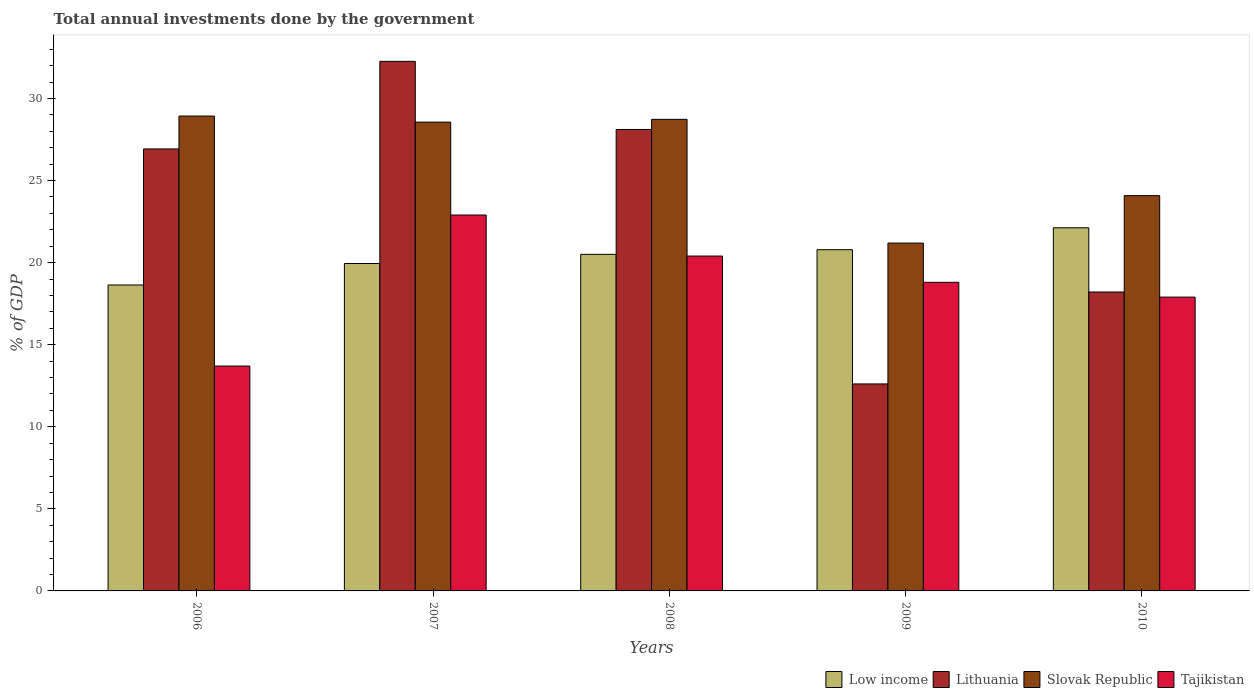How many different coloured bars are there?
Make the answer very short. 4. Are the number of bars per tick equal to the number of legend labels?
Ensure brevity in your answer.  Yes. How many bars are there on the 1st tick from the right?
Keep it short and to the point. 4. What is the label of the 3rd group of bars from the left?
Provide a succinct answer. 2008. In how many cases, is the number of bars for a given year not equal to the number of legend labels?
Provide a succinct answer. 0. What is the total annual investments done by the government in Lithuania in 2006?
Offer a terse response. 26.93. Across all years, what is the maximum total annual investments done by the government in Tajikistan?
Ensure brevity in your answer.  22.9. Across all years, what is the minimum total annual investments done by the government in Low income?
Ensure brevity in your answer.  18.64. What is the total total annual investments done by the government in Low income in the graph?
Keep it short and to the point. 102. What is the difference between the total annual investments done by the government in Lithuania in 2006 and that in 2009?
Provide a succinct answer. 14.32. What is the difference between the total annual investments done by the government in Tajikistan in 2010 and the total annual investments done by the government in Lithuania in 2006?
Ensure brevity in your answer.  -9.03. What is the average total annual investments done by the government in Low income per year?
Give a very brief answer. 20.4. In the year 2009, what is the difference between the total annual investments done by the government in Lithuania and total annual investments done by the government in Slovak Republic?
Your answer should be compact. -8.58. In how many years, is the total annual investments done by the government in Slovak Republic greater than 11 %?
Give a very brief answer. 5. What is the ratio of the total annual investments done by the government in Tajikistan in 2006 to that in 2009?
Offer a terse response. 0.73. Is the difference between the total annual investments done by the government in Lithuania in 2006 and 2009 greater than the difference between the total annual investments done by the government in Slovak Republic in 2006 and 2009?
Keep it short and to the point. Yes. What is the difference between the highest and the second highest total annual investments done by the government in Low income?
Offer a very short reply. 1.34. What is the difference between the highest and the lowest total annual investments done by the government in Lithuania?
Offer a terse response. 19.65. In how many years, is the total annual investments done by the government in Slovak Republic greater than the average total annual investments done by the government in Slovak Republic taken over all years?
Keep it short and to the point. 3. Is the sum of the total annual investments done by the government in Lithuania in 2007 and 2010 greater than the maximum total annual investments done by the government in Low income across all years?
Offer a very short reply. Yes. What does the 2nd bar from the left in 2009 represents?
Your response must be concise. Lithuania. What does the 1st bar from the right in 2010 represents?
Offer a very short reply. Tajikistan. Is it the case that in every year, the sum of the total annual investments done by the government in Lithuania and total annual investments done by the government in Low income is greater than the total annual investments done by the government in Slovak Republic?
Ensure brevity in your answer.  Yes. How many bars are there?
Give a very brief answer. 20. How many years are there in the graph?
Keep it short and to the point. 5. Does the graph contain any zero values?
Give a very brief answer. No. Does the graph contain grids?
Offer a terse response. No. How are the legend labels stacked?
Give a very brief answer. Horizontal. What is the title of the graph?
Ensure brevity in your answer.  Total annual investments done by the government. Does "India" appear as one of the legend labels in the graph?
Provide a succinct answer. No. What is the label or title of the Y-axis?
Provide a short and direct response. % of GDP. What is the % of GDP of Low income in 2006?
Your response must be concise. 18.64. What is the % of GDP of Lithuania in 2006?
Give a very brief answer. 26.93. What is the % of GDP in Slovak Republic in 2006?
Provide a short and direct response. 28.93. What is the % of GDP of Low income in 2007?
Provide a short and direct response. 19.95. What is the % of GDP in Lithuania in 2007?
Provide a succinct answer. 32.26. What is the % of GDP of Slovak Republic in 2007?
Make the answer very short. 28.56. What is the % of GDP in Tajikistan in 2007?
Keep it short and to the point. 22.9. What is the % of GDP of Low income in 2008?
Make the answer very short. 20.5. What is the % of GDP in Lithuania in 2008?
Keep it short and to the point. 28.11. What is the % of GDP in Slovak Republic in 2008?
Provide a succinct answer. 28.73. What is the % of GDP in Tajikistan in 2008?
Your response must be concise. 20.4. What is the % of GDP in Low income in 2009?
Ensure brevity in your answer.  20.79. What is the % of GDP of Lithuania in 2009?
Keep it short and to the point. 12.61. What is the % of GDP in Slovak Republic in 2009?
Your response must be concise. 21.19. What is the % of GDP of Low income in 2010?
Your answer should be very brief. 22.12. What is the % of GDP in Lithuania in 2010?
Your response must be concise. 18.21. What is the % of GDP in Slovak Republic in 2010?
Ensure brevity in your answer.  24.08. What is the % of GDP in Tajikistan in 2010?
Provide a succinct answer. 17.9. Across all years, what is the maximum % of GDP in Low income?
Provide a succinct answer. 22.12. Across all years, what is the maximum % of GDP of Lithuania?
Your answer should be very brief. 32.26. Across all years, what is the maximum % of GDP in Slovak Republic?
Your answer should be very brief. 28.93. Across all years, what is the maximum % of GDP of Tajikistan?
Provide a short and direct response. 22.9. Across all years, what is the minimum % of GDP in Low income?
Make the answer very short. 18.64. Across all years, what is the minimum % of GDP of Lithuania?
Provide a short and direct response. 12.61. Across all years, what is the minimum % of GDP in Slovak Republic?
Give a very brief answer. 21.19. Across all years, what is the minimum % of GDP in Tajikistan?
Ensure brevity in your answer.  13.7. What is the total % of GDP in Low income in the graph?
Provide a short and direct response. 102. What is the total % of GDP in Lithuania in the graph?
Make the answer very short. 118.12. What is the total % of GDP in Slovak Republic in the graph?
Provide a short and direct response. 131.49. What is the total % of GDP of Tajikistan in the graph?
Your answer should be compact. 93.7. What is the difference between the % of GDP of Low income in 2006 and that in 2007?
Offer a very short reply. -1.31. What is the difference between the % of GDP of Lithuania in 2006 and that in 2007?
Your answer should be very brief. -5.33. What is the difference between the % of GDP of Slovak Republic in 2006 and that in 2007?
Give a very brief answer. 0.37. What is the difference between the % of GDP in Low income in 2006 and that in 2008?
Offer a very short reply. -1.87. What is the difference between the % of GDP in Lithuania in 2006 and that in 2008?
Your answer should be compact. -1.19. What is the difference between the % of GDP of Slovak Republic in 2006 and that in 2008?
Provide a succinct answer. 0.2. What is the difference between the % of GDP of Tajikistan in 2006 and that in 2008?
Offer a very short reply. -6.7. What is the difference between the % of GDP of Low income in 2006 and that in 2009?
Your answer should be compact. -2.15. What is the difference between the % of GDP of Lithuania in 2006 and that in 2009?
Your answer should be compact. 14.32. What is the difference between the % of GDP in Slovak Republic in 2006 and that in 2009?
Keep it short and to the point. 7.74. What is the difference between the % of GDP of Tajikistan in 2006 and that in 2009?
Provide a succinct answer. -5.1. What is the difference between the % of GDP of Low income in 2006 and that in 2010?
Offer a very short reply. -3.48. What is the difference between the % of GDP of Lithuania in 2006 and that in 2010?
Keep it short and to the point. 8.72. What is the difference between the % of GDP of Slovak Republic in 2006 and that in 2010?
Your answer should be very brief. 4.85. What is the difference between the % of GDP of Low income in 2007 and that in 2008?
Provide a short and direct response. -0.56. What is the difference between the % of GDP in Lithuania in 2007 and that in 2008?
Ensure brevity in your answer.  4.15. What is the difference between the % of GDP in Slovak Republic in 2007 and that in 2008?
Make the answer very short. -0.17. What is the difference between the % of GDP in Low income in 2007 and that in 2009?
Your response must be concise. -0.84. What is the difference between the % of GDP of Lithuania in 2007 and that in 2009?
Offer a very short reply. 19.65. What is the difference between the % of GDP in Slovak Republic in 2007 and that in 2009?
Your answer should be very brief. 7.37. What is the difference between the % of GDP in Tajikistan in 2007 and that in 2009?
Ensure brevity in your answer.  4.1. What is the difference between the % of GDP of Low income in 2007 and that in 2010?
Ensure brevity in your answer.  -2.18. What is the difference between the % of GDP in Lithuania in 2007 and that in 2010?
Provide a short and direct response. 14.05. What is the difference between the % of GDP in Slovak Republic in 2007 and that in 2010?
Provide a succinct answer. 4.48. What is the difference between the % of GDP in Low income in 2008 and that in 2009?
Your answer should be compact. -0.28. What is the difference between the % of GDP of Lithuania in 2008 and that in 2009?
Offer a very short reply. 15.5. What is the difference between the % of GDP in Slovak Republic in 2008 and that in 2009?
Give a very brief answer. 7.54. What is the difference between the % of GDP of Low income in 2008 and that in 2010?
Keep it short and to the point. -1.62. What is the difference between the % of GDP in Lithuania in 2008 and that in 2010?
Make the answer very short. 9.9. What is the difference between the % of GDP in Slovak Republic in 2008 and that in 2010?
Your answer should be very brief. 4.65. What is the difference between the % of GDP in Low income in 2009 and that in 2010?
Give a very brief answer. -1.34. What is the difference between the % of GDP of Lithuania in 2009 and that in 2010?
Offer a very short reply. -5.6. What is the difference between the % of GDP in Slovak Republic in 2009 and that in 2010?
Give a very brief answer. -2.89. What is the difference between the % of GDP of Low income in 2006 and the % of GDP of Lithuania in 2007?
Provide a short and direct response. -13.62. What is the difference between the % of GDP in Low income in 2006 and the % of GDP in Slovak Republic in 2007?
Your response must be concise. -9.92. What is the difference between the % of GDP in Low income in 2006 and the % of GDP in Tajikistan in 2007?
Provide a succinct answer. -4.26. What is the difference between the % of GDP of Lithuania in 2006 and the % of GDP of Slovak Republic in 2007?
Your answer should be compact. -1.63. What is the difference between the % of GDP in Lithuania in 2006 and the % of GDP in Tajikistan in 2007?
Ensure brevity in your answer.  4.03. What is the difference between the % of GDP of Slovak Republic in 2006 and the % of GDP of Tajikistan in 2007?
Offer a terse response. 6.03. What is the difference between the % of GDP in Low income in 2006 and the % of GDP in Lithuania in 2008?
Ensure brevity in your answer.  -9.47. What is the difference between the % of GDP in Low income in 2006 and the % of GDP in Slovak Republic in 2008?
Give a very brief answer. -10.09. What is the difference between the % of GDP in Low income in 2006 and the % of GDP in Tajikistan in 2008?
Offer a terse response. -1.76. What is the difference between the % of GDP in Lithuania in 2006 and the % of GDP in Slovak Republic in 2008?
Offer a terse response. -1.8. What is the difference between the % of GDP in Lithuania in 2006 and the % of GDP in Tajikistan in 2008?
Keep it short and to the point. 6.53. What is the difference between the % of GDP in Slovak Republic in 2006 and the % of GDP in Tajikistan in 2008?
Your answer should be very brief. 8.53. What is the difference between the % of GDP in Low income in 2006 and the % of GDP in Lithuania in 2009?
Ensure brevity in your answer.  6.03. What is the difference between the % of GDP in Low income in 2006 and the % of GDP in Slovak Republic in 2009?
Offer a terse response. -2.55. What is the difference between the % of GDP of Low income in 2006 and the % of GDP of Tajikistan in 2009?
Keep it short and to the point. -0.16. What is the difference between the % of GDP of Lithuania in 2006 and the % of GDP of Slovak Republic in 2009?
Ensure brevity in your answer.  5.74. What is the difference between the % of GDP in Lithuania in 2006 and the % of GDP in Tajikistan in 2009?
Provide a short and direct response. 8.13. What is the difference between the % of GDP of Slovak Republic in 2006 and the % of GDP of Tajikistan in 2009?
Your response must be concise. 10.13. What is the difference between the % of GDP of Low income in 2006 and the % of GDP of Lithuania in 2010?
Provide a succinct answer. 0.43. What is the difference between the % of GDP in Low income in 2006 and the % of GDP in Slovak Republic in 2010?
Provide a short and direct response. -5.44. What is the difference between the % of GDP of Low income in 2006 and the % of GDP of Tajikistan in 2010?
Keep it short and to the point. 0.74. What is the difference between the % of GDP in Lithuania in 2006 and the % of GDP in Slovak Republic in 2010?
Your answer should be very brief. 2.85. What is the difference between the % of GDP of Lithuania in 2006 and the % of GDP of Tajikistan in 2010?
Your answer should be very brief. 9.03. What is the difference between the % of GDP in Slovak Republic in 2006 and the % of GDP in Tajikistan in 2010?
Your answer should be very brief. 11.03. What is the difference between the % of GDP in Low income in 2007 and the % of GDP in Lithuania in 2008?
Ensure brevity in your answer.  -8.17. What is the difference between the % of GDP of Low income in 2007 and the % of GDP of Slovak Republic in 2008?
Ensure brevity in your answer.  -8.78. What is the difference between the % of GDP of Low income in 2007 and the % of GDP of Tajikistan in 2008?
Your answer should be very brief. -0.45. What is the difference between the % of GDP in Lithuania in 2007 and the % of GDP in Slovak Republic in 2008?
Keep it short and to the point. 3.53. What is the difference between the % of GDP of Lithuania in 2007 and the % of GDP of Tajikistan in 2008?
Your answer should be compact. 11.86. What is the difference between the % of GDP in Slovak Republic in 2007 and the % of GDP in Tajikistan in 2008?
Provide a short and direct response. 8.16. What is the difference between the % of GDP in Low income in 2007 and the % of GDP in Lithuania in 2009?
Offer a terse response. 7.34. What is the difference between the % of GDP in Low income in 2007 and the % of GDP in Slovak Republic in 2009?
Make the answer very short. -1.25. What is the difference between the % of GDP of Low income in 2007 and the % of GDP of Tajikistan in 2009?
Ensure brevity in your answer.  1.15. What is the difference between the % of GDP in Lithuania in 2007 and the % of GDP in Slovak Republic in 2009?
Your answer should be very brief. 11.07. What is the difference between the % of GDP in Lithuania in 2007 and the % of GDP in Tajikistan in 2009?
Give a very brief answer. 13.46. What is the difference between the % of GDP in Slovak Republic in 2007 and the % of GDP in Tajikistan in 2009?
Provide a short and direct response. 9.76. What is the difference between the % of GDP of Low income in 2007 and the % of GDP of Lithuania in 2010?
Ensure brevity in your answer.  1.74. What is the difference between the % of GDP of Low income in 2007 and the % of GDP of Slovak Republic in 2010?
Keep it short and to the point. -4.14. What is the difference between the % of GDP of Low income in 2007 and the % of GDP of Tajikistan in 2010?
Your response must be concise. 2.05. What is the difference between the % of GDP in Lithuania in 2007 and the % of GDP in Slovak Republic in 2010?
Offer a terse response. 8.18. What is the difference between the % of GDP of Lithuania in 2007 and the % of GDP of Tajikistan in 2010?
Your answer should be very brief. 14.36. What is the difference between the % of GDP of Slovak Republic in 2007 and the % of GDP of Tajikistan in 2010?
Provide a short and direct response. 10.66. What is the difference between the % of GDP of Low income in 2008 and the % of GDP of Lithuania in 2009?
Your response must be concise. 7.89. What is the difference between the % of GDP of Low income in 2008 and the % of GDP of Slovak Republic in 2009?
Offer a terse response. -0.69. What is the difference between the % of GDP of Low income in 2008 and the % of GDP of Tajikistan in 2009?
Make the answer very short. 1.7. What is the difference between the % of GDP of Lithuania in 2008 and the % of GDP of Slovak Republic in 2009?
Offer a very short reply. 6.92. What is the difference between the % of GDP in Lithuania in 2008 and the % of GDP in Tajikistan in 2009?
Give a very brief answer. 9.31. What is the difference between the % of GDP of Slovak Republic in 2008 and the % of GDP of Tajikistan in 2009?
Give a very brief answer. 9.93. What is the difference between the % of GDP of Low income in 2008 and the % of GDP of Lithuania in 2010?
Provide a succinct answer. 2.29. What is the difference between the % of GDP of Low income in 2008 and the % of GDP of Slovak Republic in 2010?
Provide a succinct answer. -3.58. What is the difference between the % of GDP in Low income in 2008 and the % of GDP in Tajikistan in 2010?
Your response must be concise. 2.6. What is the difference between the % of GDP of Lithuania in 2008 and the % of GDP of Slovak Republic in 2010?
Offer a very short reply. 4.03. What is the difference between the % of GDP of Lithuania in 2008 and the % of GDP of Tajikistan in 2010?
Offer a terse response. 10.21. What is the difference between the % of GDP of Slovak Republic in 2008 and the % of GDP of Tajikistan in 2010?
Offer a very short reply. 10.83. What is the difference between the % of GDP of Low income in 2009 and the % of GDP of Lithuania in 2010?
Offer a terse response. 2.58. What is the difference between the % of GDP of Low income in 2009 and the % of GDP of Slovak Republic in 2010?
Offer a very short reply. -3.29. What is the difference between the % of GDP in Low income in 2009 and the % of GDP in Tajikistan in 2010?
Give a very brief answer. 2.89. What is the difference between the % of GDP in Lithuania in 2009 and the % of GDP in Slovak Republic in 2010?
Your answer should be very brief. -11.47. What is the difference between the % of GDP of Lithuania in 2009 and the % of GDP of Tajikistan in 2010?
Ensure brevity in your answer.  -5.29. What is the difference between the % of GDP of Slovak Republic in 2009 and the % of GDP of Tajikistan in 2010?
Provide a succinct answer. 3.29. What is the average % of GDP in Low income per year?
Provide a short and direct response. 20.4. What is the average % of GDP in Lithuania per year?
Offer a terse response. 23.62. What is the average % of GDP in Slovak Republic per year?
Your answer should be compact. 26.3. What is the average % of GDP in Tajikistan per year?
Ensure brevity in your answer.  18.74. In the year 2006, what is the difference between the % of GDP of Low income and % of GDP of Lithuania?
Offer a very short reply. -8.29. In the year 2006, what is the difference between the % of GDP of Low income and % of GDP of Slovak Republic?
Provide a short and direct response. -10.29. In the year 2006, what is the difference between the % of GDP in Low income and % of GDP in Tajikistan?
Ensure brevity in your answer.  4.94. In the year 2006, what is the difference between the % of GDP of Lithuania and % of GDP of Slovak Republic?
Your answer should be very brief. -2. In the year 2006, what is the difference between the % of GDP in Lithuania and % of GDP in Tajikistan?
Make the answer very short. 13.23. In the year 2006, what is the difference between the % of GDP of Slovak Republic and % of GDP of Tajikistan?
Your answer should be very brief. 15.23. In the year 2007, what is the difference between the % of GDP of Low income and % of GDP of Lithuania?
Your answer should be compact. -12.32. In the year 2007, what is the difference between the % of GDP in Low income and % of GDP in Slovak Republic?
Provide a short and direct response. -8.61. In the year 2007, what is the difference between the % of GDP in Low income and % of GDP in Tajikistan?
Provide a succinct answer. -2.95. In the year 2007, what is the difference between the % of GDP of Lithuania and % of GDP of Slovak Republic?
Your answer should be very brief. 3.7. In the year 2007, what is the difference between the % of GDP of Lithuania and % of GDP of Tajikistan?
Provide a short and direct response. 9.36. In the year 2007, what is the difference between the % of GDP of Slovak Republic and % of GDP of Tajikistan?
Offer a very short reply. 5.66. In the year 2008, what is the difference between the % of GDP in Low income and % of GDP in Lithuania?
Ensure brevity in your answer.  -7.61. In the year 2008, what is the difference between the % of GDP of Low income and % of GDP of Slovak Republic?
Keep it short and to the point. -8.22. In the year 2008, what is the difference between the % of GDP of Low income and % of GDP of Tajikistan?
Offer a very short reply. 0.1. In the year 2008, what is the difference between the % of GDP in Lithuania and % of GDP in Slovak Republic?
Provide a short and direct response. -0.62. In the year 2008, what is the difference between the % of GDP in Lithuania and % of GDP in Tajikistan?
Ensure brevity in your answer.  7.71. In the year 2008, what is the difference between the % of GDP of Slovak Republic and % of GDP of Tajikistan?
Offer a terse response. 8.33. In the year 2009, what is the difference between the % of GDP of Low income and % of GDP of Lithuania?
Make the answer very short. 8.18. In the year 2009, what is the difference between the % of GDP in Low income and % of GDP in Slovak Republic?
Offer a very short reply. -0.4. In the year 2009, what is the difference between the % of GDP of Low income and % of GDP of Tajikistan?
Give a very brief answer. 1.99. In the year 2009, what is the difference between the % of GDP of Lithuania and % of GDP of Slovak Republic?
Your answer should be very brief. -8.58. In the year 2009, what is the difference between the % of GDP of Lithuania and % of GDP of Tajikistan?
Give a very brief answer. -6.19. In the year 2009, what is the difference between the % of GDP of Slovak Republic and % of GDP of Tajikistan?
Your answer should be very brief. 2.39. In the year 2010, what is the difference between the % of GDP of Low income and % of GDP of Lithuania?
Your answer should be compact. 3.91. In the year 2010, what is the difference between the % of GDP in Low income and % of GDP in Slovak Republic?
Ensure brevity in your answer.  -1.96. In the year 2010, what is the difference between the % of GDP in Low income and % of GDP in Tajikistan?
Your response must be concise. 4.22. In the year 2010, what is the difference between the % of GDP of Lithuania and % of GDP of Slovak Republic?
Offer a very short reply. -5.87. In the year 2010, what is the difference between the % of GDP in Lithuania and % of GDP in Tajikistan?
Offer a terse response. 0.31. In the year 2010, what is the difference between the % of GDP of Slovak Republic and % of GDP of Tajikistan?
Your answer should be compact. 6.18. What is the ratio of the % of GDP in Low income in 2006 to that in 2007?
Your answer should be very brief. 0.93. What is the ratio of the % of GDP in Lithuania in 2006 to that in 2007?
Offer a very short reply. 0.83. What is the ratio of the % of GDP in Slovak Republic in 2006 to that in 2007?
Offer a very short reply. 1.01. What is the ratio of the % of GDP of Tajikistan in 2006 to that in 2007?
Make the answer very short. 0.6. What is the ratio of the % of GDP of Low income in 2006 to that in 2008?
Provide a succinct answer. 0.91. What is the ratio of the % of GDP of Lithuania in 2006 to that in 2008?
Your answer should be compact. 0.96. What is the ratio of the % of GDP in Tajikistan in 2006 to that in 2008?
Give a very brief answer. 0.67. What is the ratio of the % of GDP in Low income in 2006 to that in 2009?
Offer a terse response. 0.9. What is the ratio of the % of GDP of Lithuania in 2006 to that in 2009?
Offer a very short reply. 2.14. What is the ratio of the % of GDP of Slovak Republic in 2006 to that in 2009?
Offer a terse response. 1.37. What is the ratio of the % of GDP in Tajikistan in 2006 to that in 2009?
Offer a terse response. 0.73. What is the ratio of the % of GDP in Low income in 2006 to that in 2010?
Keep it short and to the point. 0.84. What is the ratio of the % of GDP in Lithuania in 2006 to that in 2010?
Offer a very short reply. 1.48. What is the ratio of the % of GDP of Slovak Republic in 2006 to that in 2010?
Your answer should be compact. 1.2. What is the ratio of the % of GDP in Tajikistan in 2006 to that in 2010?
Provide a succinct answer. 0.77. What is the ratio of the % of GDP in Low income in 2007 to that in 2008?
Offer a terse response. 0.97. What is the ratio of the % of GDP of Lithuania in 2007 to that in 2008?
Provide a succinct answer. 1.15. What is the ratio of the % of GDP of Tajikistan in 2007 to that in 2008?
Provide a short and direct response. 1.12. What is the ratio of the % of GDP in Low income in 2007 to that in 2009?
Provide a succinct answer. 0.96. What is the ratio of the % of GDP of Lithuania in 2007 to that in 2009?
Make the answer very short. 2.56. What is the ratio of the % of GDP in Slovak Republic in 2007 to that in 2009?
Offer a very short reply. 1.35. What is the ratio of the % of GDP in Tajikistan in 2007 to that in 2009?
Ensure brevity in your answer.  1.22. What is the ratio of the % of GDP of Low income in 2007 to that in 2010?
Your response must be concise. 0.9. What is the ratio of the % of GDP of Lithuania in 2007 to that in 2010?
Offer a terse response. 1.77. What is the ratio of the % of GDP of Slovak Republic in 2007 to that in 2010?
Offer a terse response. 1.19. What is the ratio of the % of GDP of Tajikistan in 2007 to that in 2010?
Provide a short and direct response. 1.28. What is the ratio of the % of GDP in Low income in 2008 to that in 2009?
Your answer should be compact. 0.99. What is the ratio of the % of GDP of Lithuania in 2008 to that in 2009?
Ensure brevity in your answer.  2.23. What is the ratio of the % of GDP in Slovak Republic in 2008 to that in 2009?
Offer a very short reply. 1.36. What is the ratio of the % of GDP in Tajikistan in 2008 to that in 2009?
Ensure brevity in your answer.  1.09. What is the ratio of the % of GDP of Low income in 2008 to that in 2010?
Offer a very short reply. 0.93. What is the ratio of the % of GDP of Lithuania in 2008 to that in 2010?
Your response must be concise. 1.54. What is the ratio of the % of GDP in Slovak Republic in 2008 to that in 2010?
Give a very brief answer. 1.19. What is the ratio of the % of GDP of Tajikistan in 2008 to that in 2010?
Provide a succinct answer. 1.14. What is the ratio of the % of GDP in Low income in 2009 to that in 2010?
Offer a terse response. 0.94. What is the ratio of the % of GDP of Lithuania in 2009 to that in 2010?
Keep it short and to the point. 0.69. What is the ratio of the % of GDP in Slovak Republic in 2009 to that in 2010?
Give a very brief answer. 0.88. What is the ratio of the % of GDP of Tajikistan in 2009 to that in 2010?
Provide a short and direct response. 1.05. What is the difference between the highest and the second highest % of GDP of Low income?
Ensure brevity in your answer.  1.34. What is the difference between the highest and the second highest % of GDP of Lithuania?
Your response must be concise. 4.15. What is the difference between the highest and the second highest % of GDP of Slovak Republic?
Provide a succinct answer. 0.2. What is the difference between the highest and the second highest % of GDP of Tajikistan?
Give a very brief answer. 2.5. What is the difference between the highest and the lowest % of GDP of Low income?
Offer a very short reply. 3.48. What is the difference between the highest and the lowest % of GDP of Lithuania?
Your response must be concise. 19.65. What is the difference between the highest and the lowest % of GDP of Slovak Republic?
Your answer should be very brief. 7.74. What is the difference between the highest and the lowest % of GDP in Tajikistan?
Your response must be concise. 9.2. 